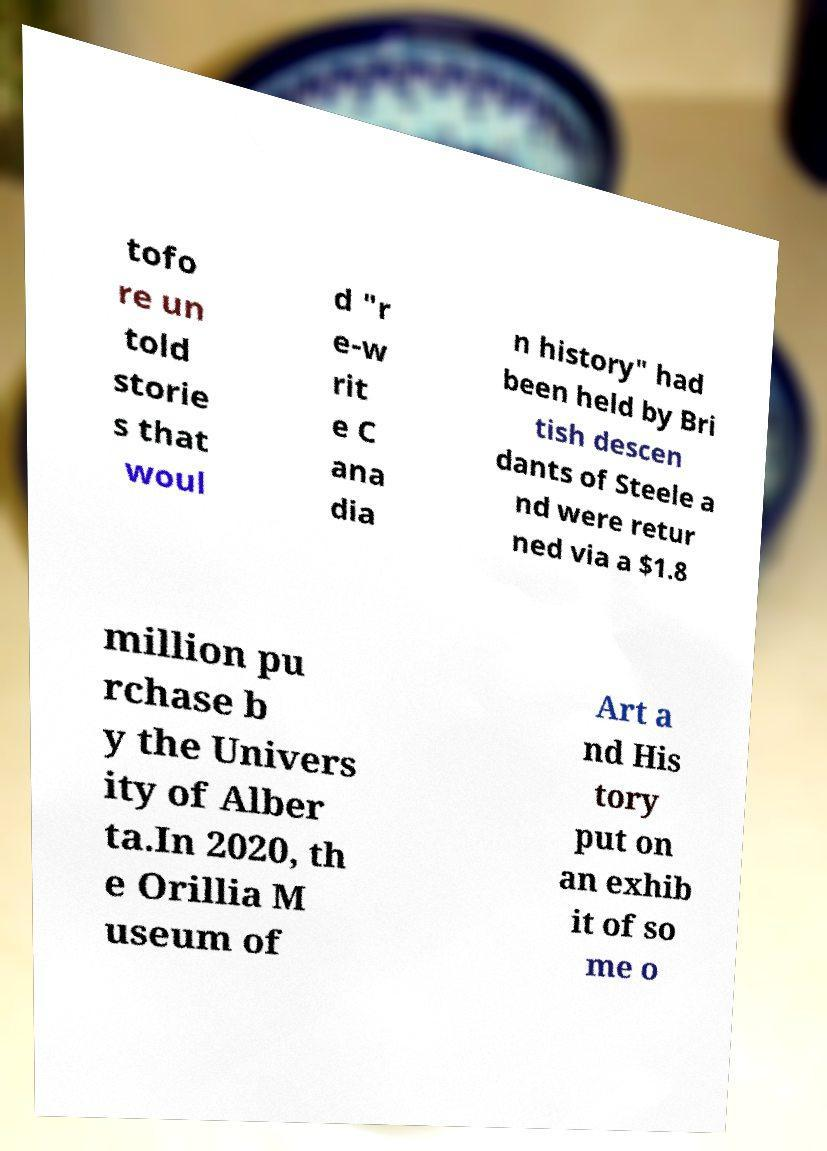I need the written content from this picture converted into text. Can you do that? tofo re un told storie s that woul d "r e-w rit e C ana dia n history" had been held by Bri tish descen dants of Steele a nd were retur ned via a $1.8 million pu rchase b y the Univers ity of Alber ta.In 2020, th e Orillia M useum of Art a nd His tory put on an exhib it of so me o 